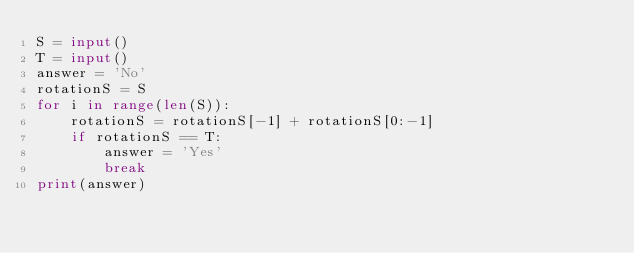<code> <loc_0><loc_0><loc_500><loc_500><_Python_>S = input()
T = input()
answer = 'No'
rotationS = S
for i in range(len(S)):
    rotationS = rotationS[-1] + rotationS[0:-1]
    if rotationS == T:
        answer = 'Yes'
        break
print(answer)</code> 